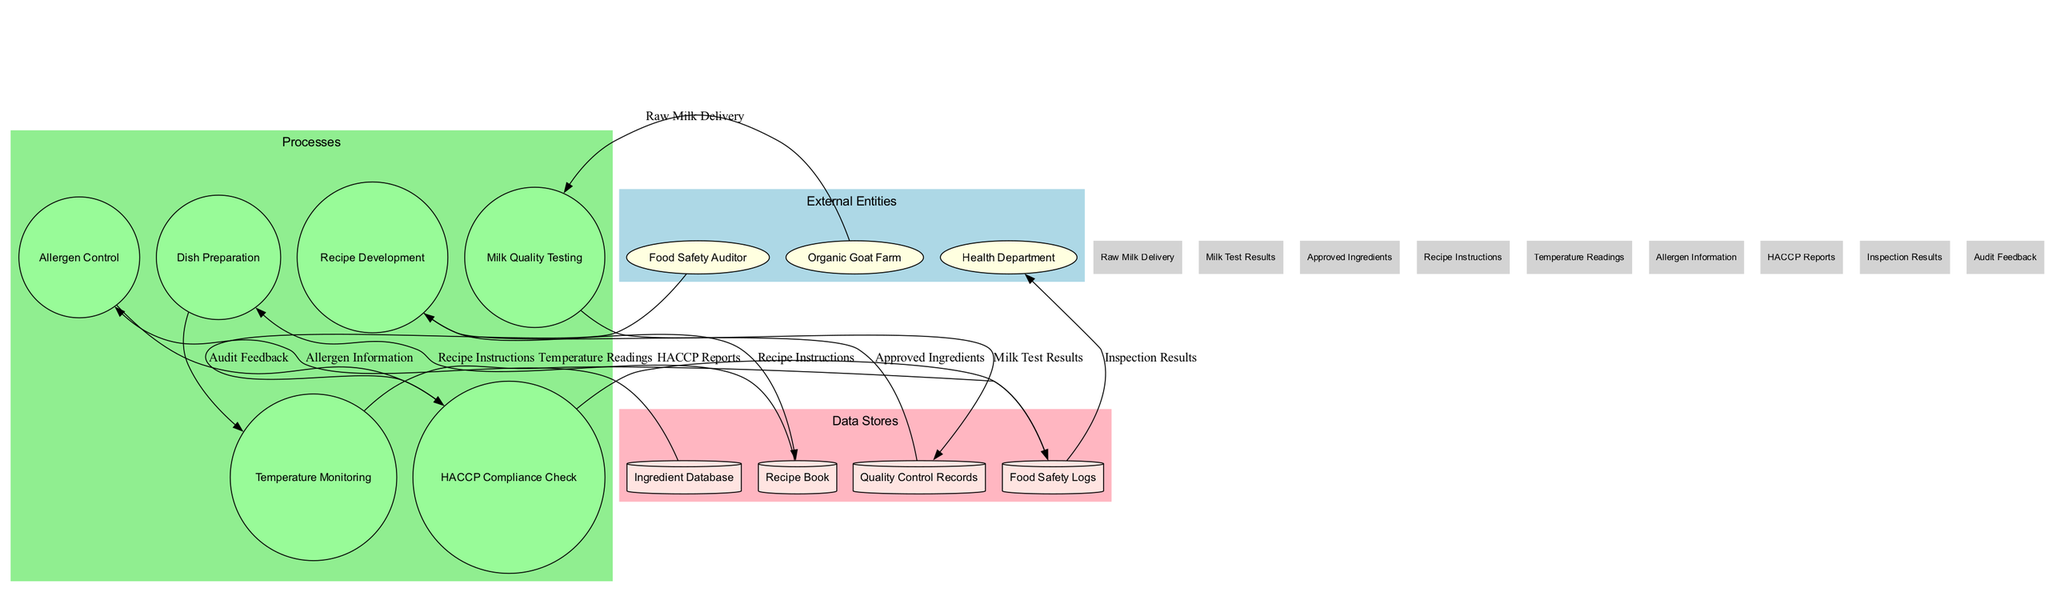What are the external entities in the diagram? The external entities are defined in the diagram, specifically listed as "Organic Goat Farm," "Health Department," and "Food Safety Auditor." These entities interact with the internal processes for quality control and food safety monitoring.
Answer: Organic Goat Farm, Health Department, Food Safety Auditor How many processes are depicted in the diagram? In the diagram, there is a total of six processes listed: "Milk Quality Testing," "Recipe Development," "Dish Preparation," "Temperature Monitoring," "Allergen Control," and "HACCP Compliance Check." By counting them, we find the total.
Answer: 6 What data flows into the "Dish Preparation" process? Analyzing the diagram, the "Dish Preparation" process receives information specifically labeled as "Recipe Instructions" from the "Recipe Book." This indicates the flow of data into the process necessary for preparation.
Answer: Recipe Instructions Which process is responsible for generating HACCP reports? The "HACCP Compliance Check" process produces the reports, specifically sending "HACCP Reports" to the "Food Safety Logs," as indicated in the connections of the diagram.
Answer: HACCP Compliance Check What happens to milk after it is tested in "Milk Quality Testing"? The "Milk Quality Testing" process results in "Milk Test Results," which are transferred to the "Quality Control Records." This sequence shows the immediate next step following testing.
Answer: Quality Control Records How many data stores are there in the diagram? The diagram features four data stores, clearly marked as "Ingredient Database," "Quality Control Records," "Recipe Book," and "Food Safety Logs." Counting them confirms the total.
Answer: 4 What is the connection between the "Food Safety Logs" and the "Health Department"? According to the diagram, the "Food Safety Logs" provide "Inspection Results" to the "Health Department," indicating a feedback loop related to health standards and inspections.
Answer: Inspection Results Which entity provides audit feedback? The "Food Safety Auditor" is responsible for supplying "Audit Feedback," which directly connects to the "HACCP Compliance Check" process, as mapped out in the data flows of the diagram.
Answer: Food Safety Auditor What type of information does the "Allergen Control" process utilize? The "Allergen Control" process requires "Allergen Information," which comes from the "Ingredient Database." This connection specifies the data utilized in allergen management.
Answer: Allergen Information 